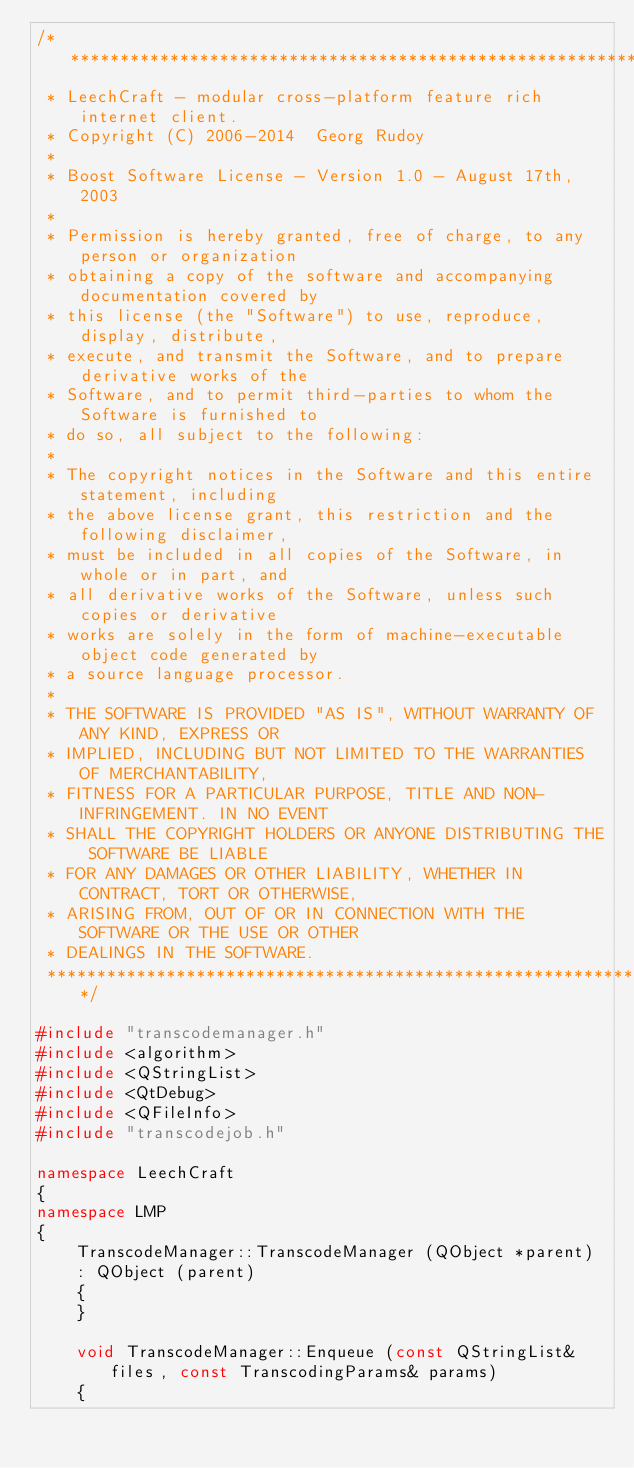<code> <loc_0><loc_0><loc_500><loc_500><_C++_>/**********************************************************************
 * LeechCraft - modular cross-platform feature rich internet client.
 * Copyright (C) 2006-2014  Georg Rudoy
 *
 * Boost Software License - Version 1.0 - August 17th, 2003
 *
 * Permission is hereby granted, free of charge, to any person or organization
 * obtaining a copy of the software and accompanying documentation covered by
 * this license (the "Software") to use, reproduce, display, distribute,
 * execute, and transmit the Software, and to prepare derivative works of the
 * Software, and to permit third-parties to whom the Software is furnished to
 * do so, all subject to the following:
 *
 * The copyright notices in the Software and this entire statement, including
 * the above license grant, this restriction and the following disclaimer,
 * must be included in all copies of the Software, in whole or in part, and
 * all derivative works of the Software, unless such copies or derivative
 * works are solely in the form of machine-executable object code generated by
 * a source language processor.
 *
 * THE SOFTWARE IS PROVIDED "AS IS", WITHOUT WARRANTY OF ANY KIND, EXPRESS OR
 * IMPLIED, INCLUDING BUT NOT LIMITED TO THE WARRANTIES OF MERCHANTABILITY,
 * FITNESS FOR A PARTICULAR PURPOSE, TITLE AND NON-INFRINGEMENT. IN NO EVENT
 * SHALL THE COPYRIGHT HOLDERS OR ANYONE DISTRIBUTING THE SOFTWARE BE LIABLE
 * FOR ANY DAMAGES OR OTHER LIABILITY, WHETHER IN CONTRACT, TORT OR OTHERWISE,
 * ARISING FROM, OUT OF OR IN CONNECTION WITH THE SOFTWARE OR THE USE OR OTHER
 * DEALINGS IN THE SOFTWARE.
 **********************************************************************/

#include "transcodemanager.h"
#include <algorithm>
#include <QStringList>
#include <QtDebug>
#include <QFileInfo>
#include "transcodejob.h"

namespace LeechCraft
{
namespace LMP
{
	TranscodeManager::TranscodeManager (QObject *parent)
	: QObject (parent)
	{
	}

	void TranscodeManager::Enqueue (const QStringList& files, const TranscodingParams& params)
	{</code> 